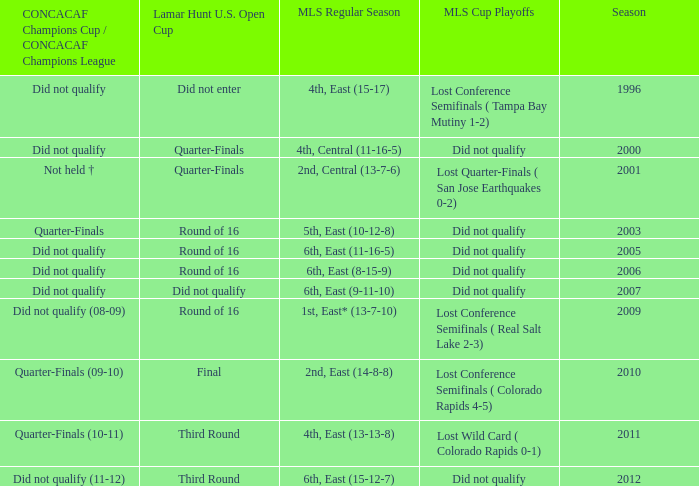What was the mls cup playoffs when the mls regular season was 4th, central (11-16-5)? Did not qualify. 